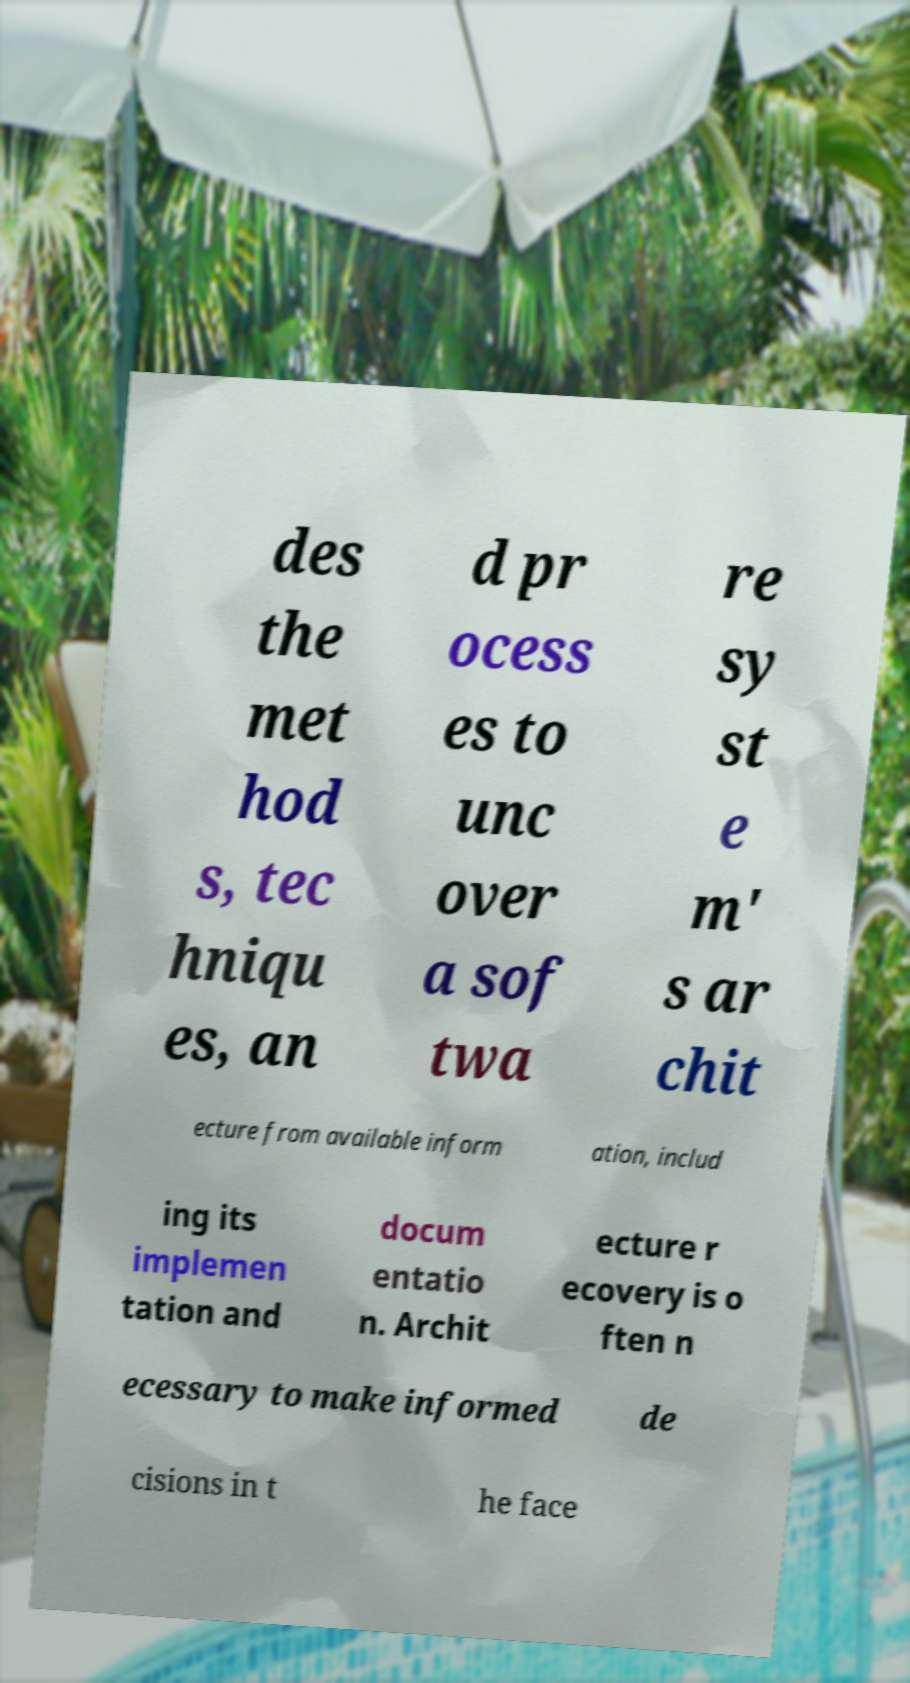Could you extract and type out the text from this image? des the met hod s, tec hniqu es, an d pr ocess es to unc over a sof twa re sy st e m' s ar chit ecture from available inform ation, includ ing its implemen tation and docum entatio n. Archit ecture r ecovery is o ften n ecessary to make informed de cisions in t he face 